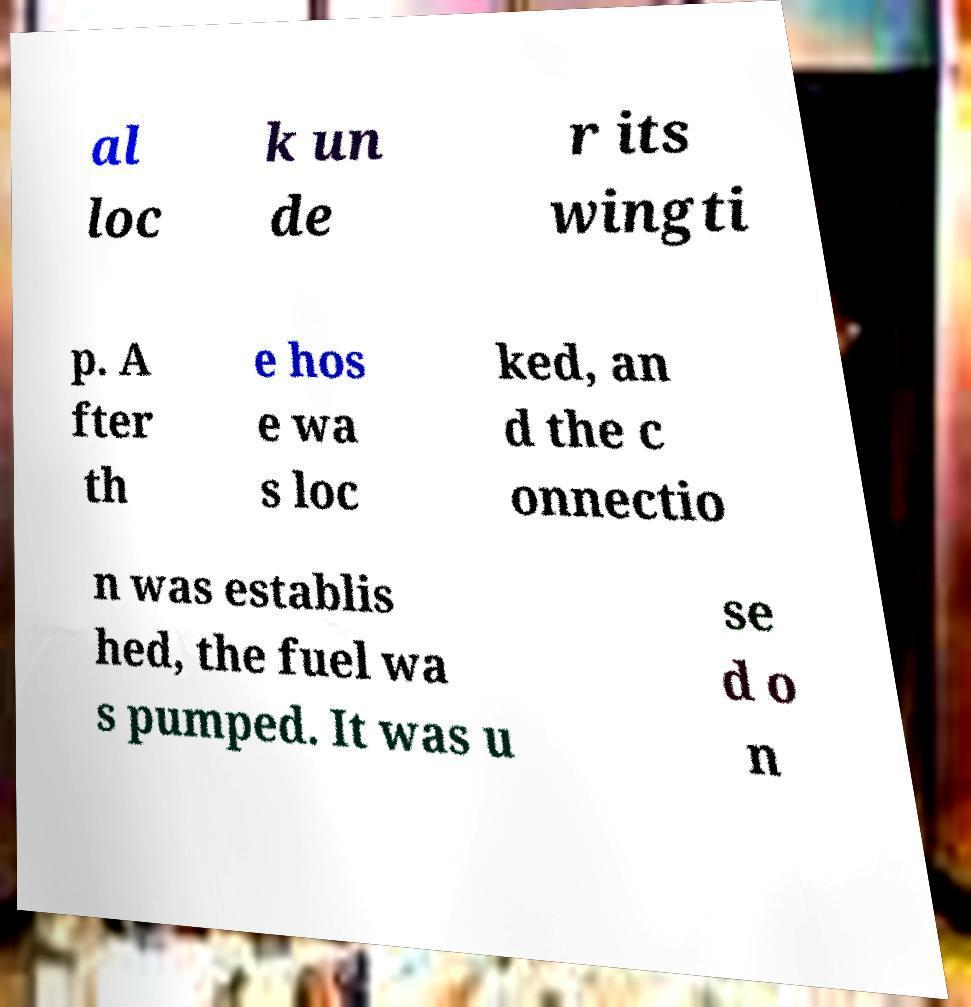Could you extract and type out the text from this image? al loc k un de r its wingti p. A fter th e hos e wa s loc ked, an d the c onnectio n was establis hed, the fuel wa s pumped. It was u se d o n 